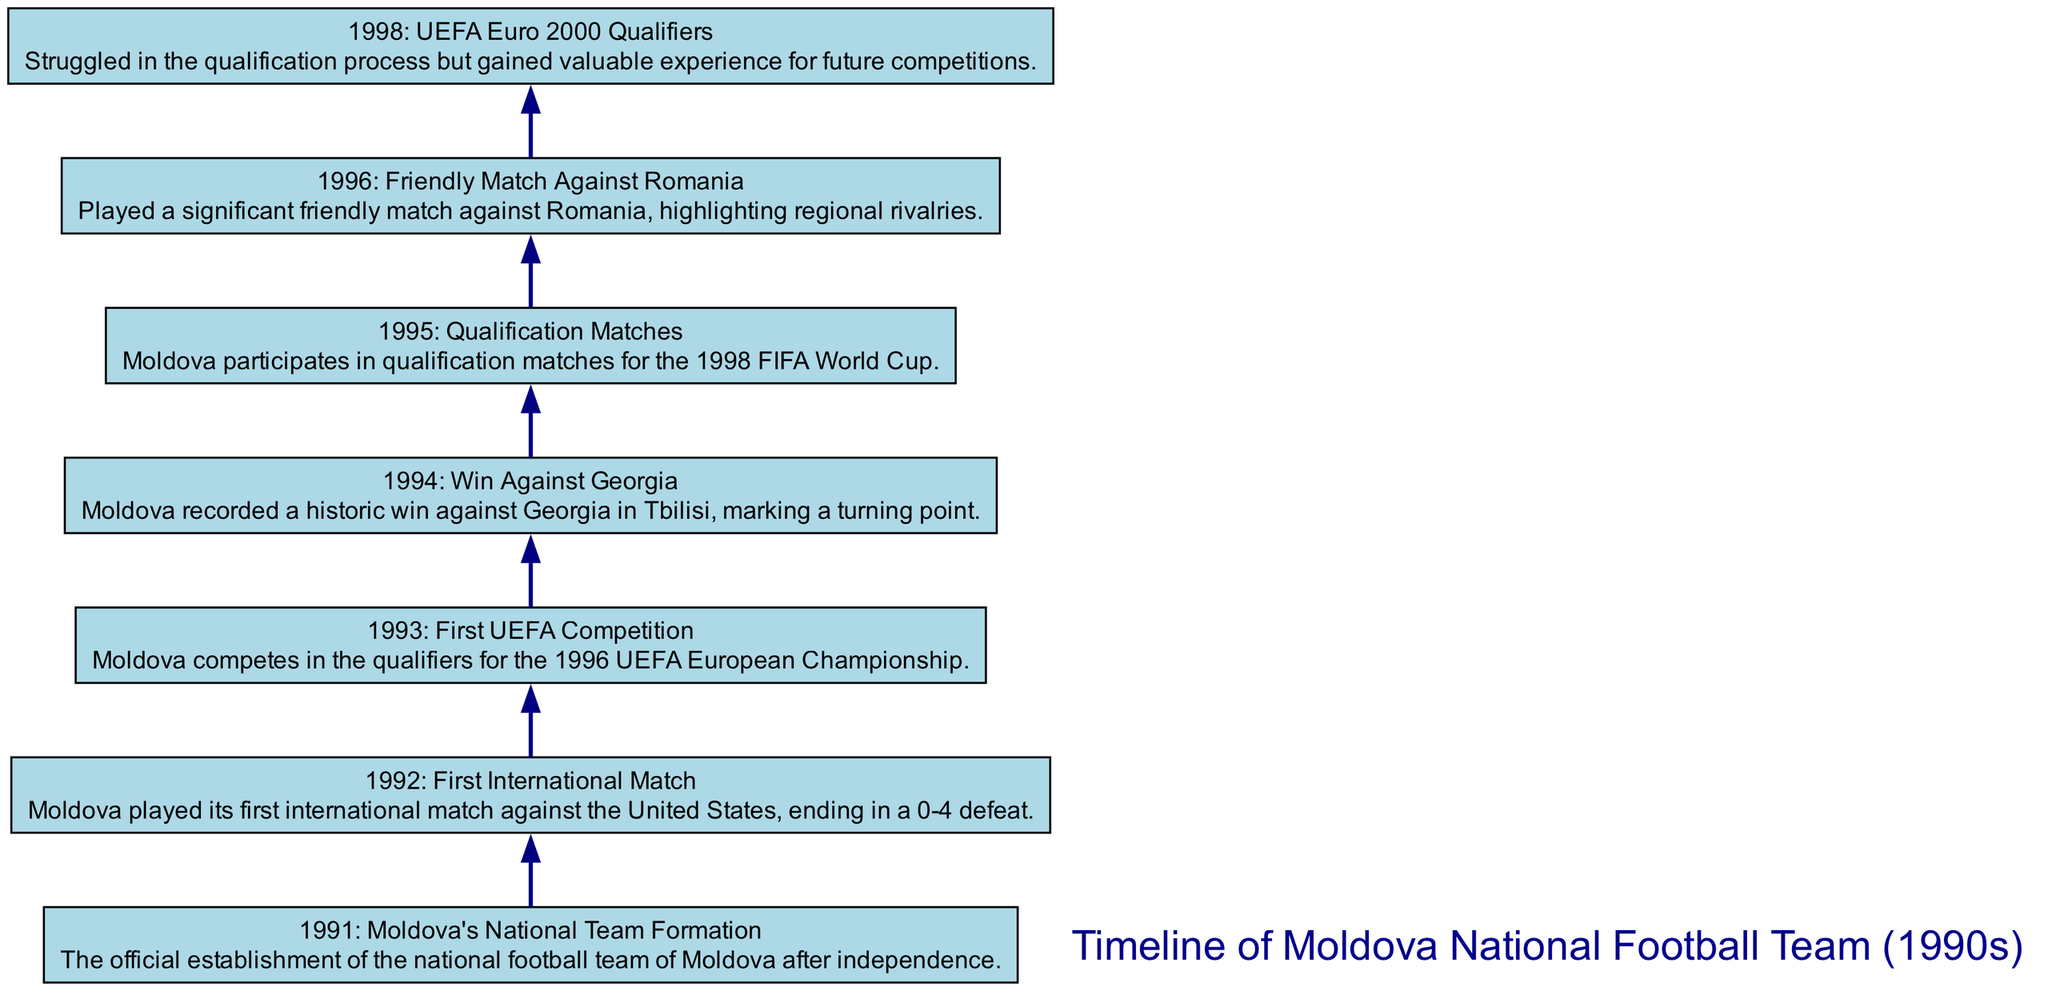What year was Moldova's national football team formed? The diagram shows that Moldova's national team was officially established in 1991.
Answer: 1991 What was the result of Moldova's first international match? According to the description, Moldova played its first international match against the United States, resulting in a score of 0-4.
Answer: 0-4 defeat Which team did Moldova achieve a significant victory against in 1994? The diagram indicates that Moldova had a historic win against Georgia in Tbilisi in 1994.
Answer: Georgia How many events are listed in the timeline? The diagram contains a total of 7 events related to the national team during the 1990s.
Answer: 7 What is the last event noted in the timeline? By looking at the last node in the diagram, it can be identified that the last event is related to the UEFA Euro 2000 qualifiers in 1998.
Answer: UEFA Euro 2000 Qualifiers What significant friendly match occurred in 1996? The timeline indicates that a significant friendly match against Romania took place in 1996.
Answer: Romania What specific competition did Moldova participate in during 1993? The diagram indicates that Moldova competed in the qualifiers for the 1996 UEFA European Championship in 1993.
Answer: UEFA European Championship qualifiers What important milestone occurred in 1994 prior to the qualification matches in 1995? Reviewing the flow of the diagram, the significant milestone in 1994 was a historic win against Georgia before the qualification matches in 1995.
Answer: Historic win against Georgia 